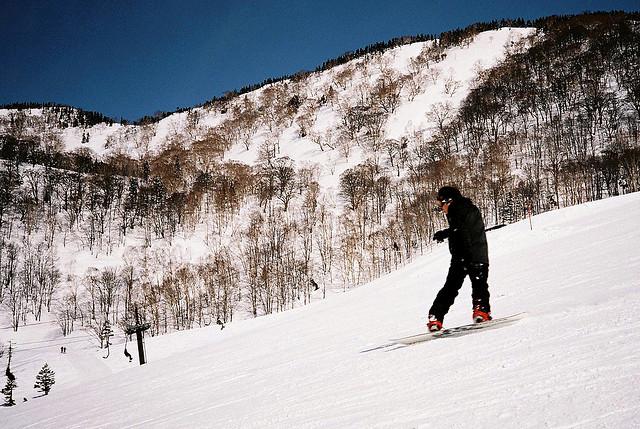Are skiers on the lift?
Answer briefly. Yes. What color is his outfit?
Answer briefly. Black. What is orange on the man?
Give a very brief answer. Boots. 